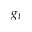<formula> <loc_0><loc_0><loc_500><loc_500>g _ { t }</formula> 